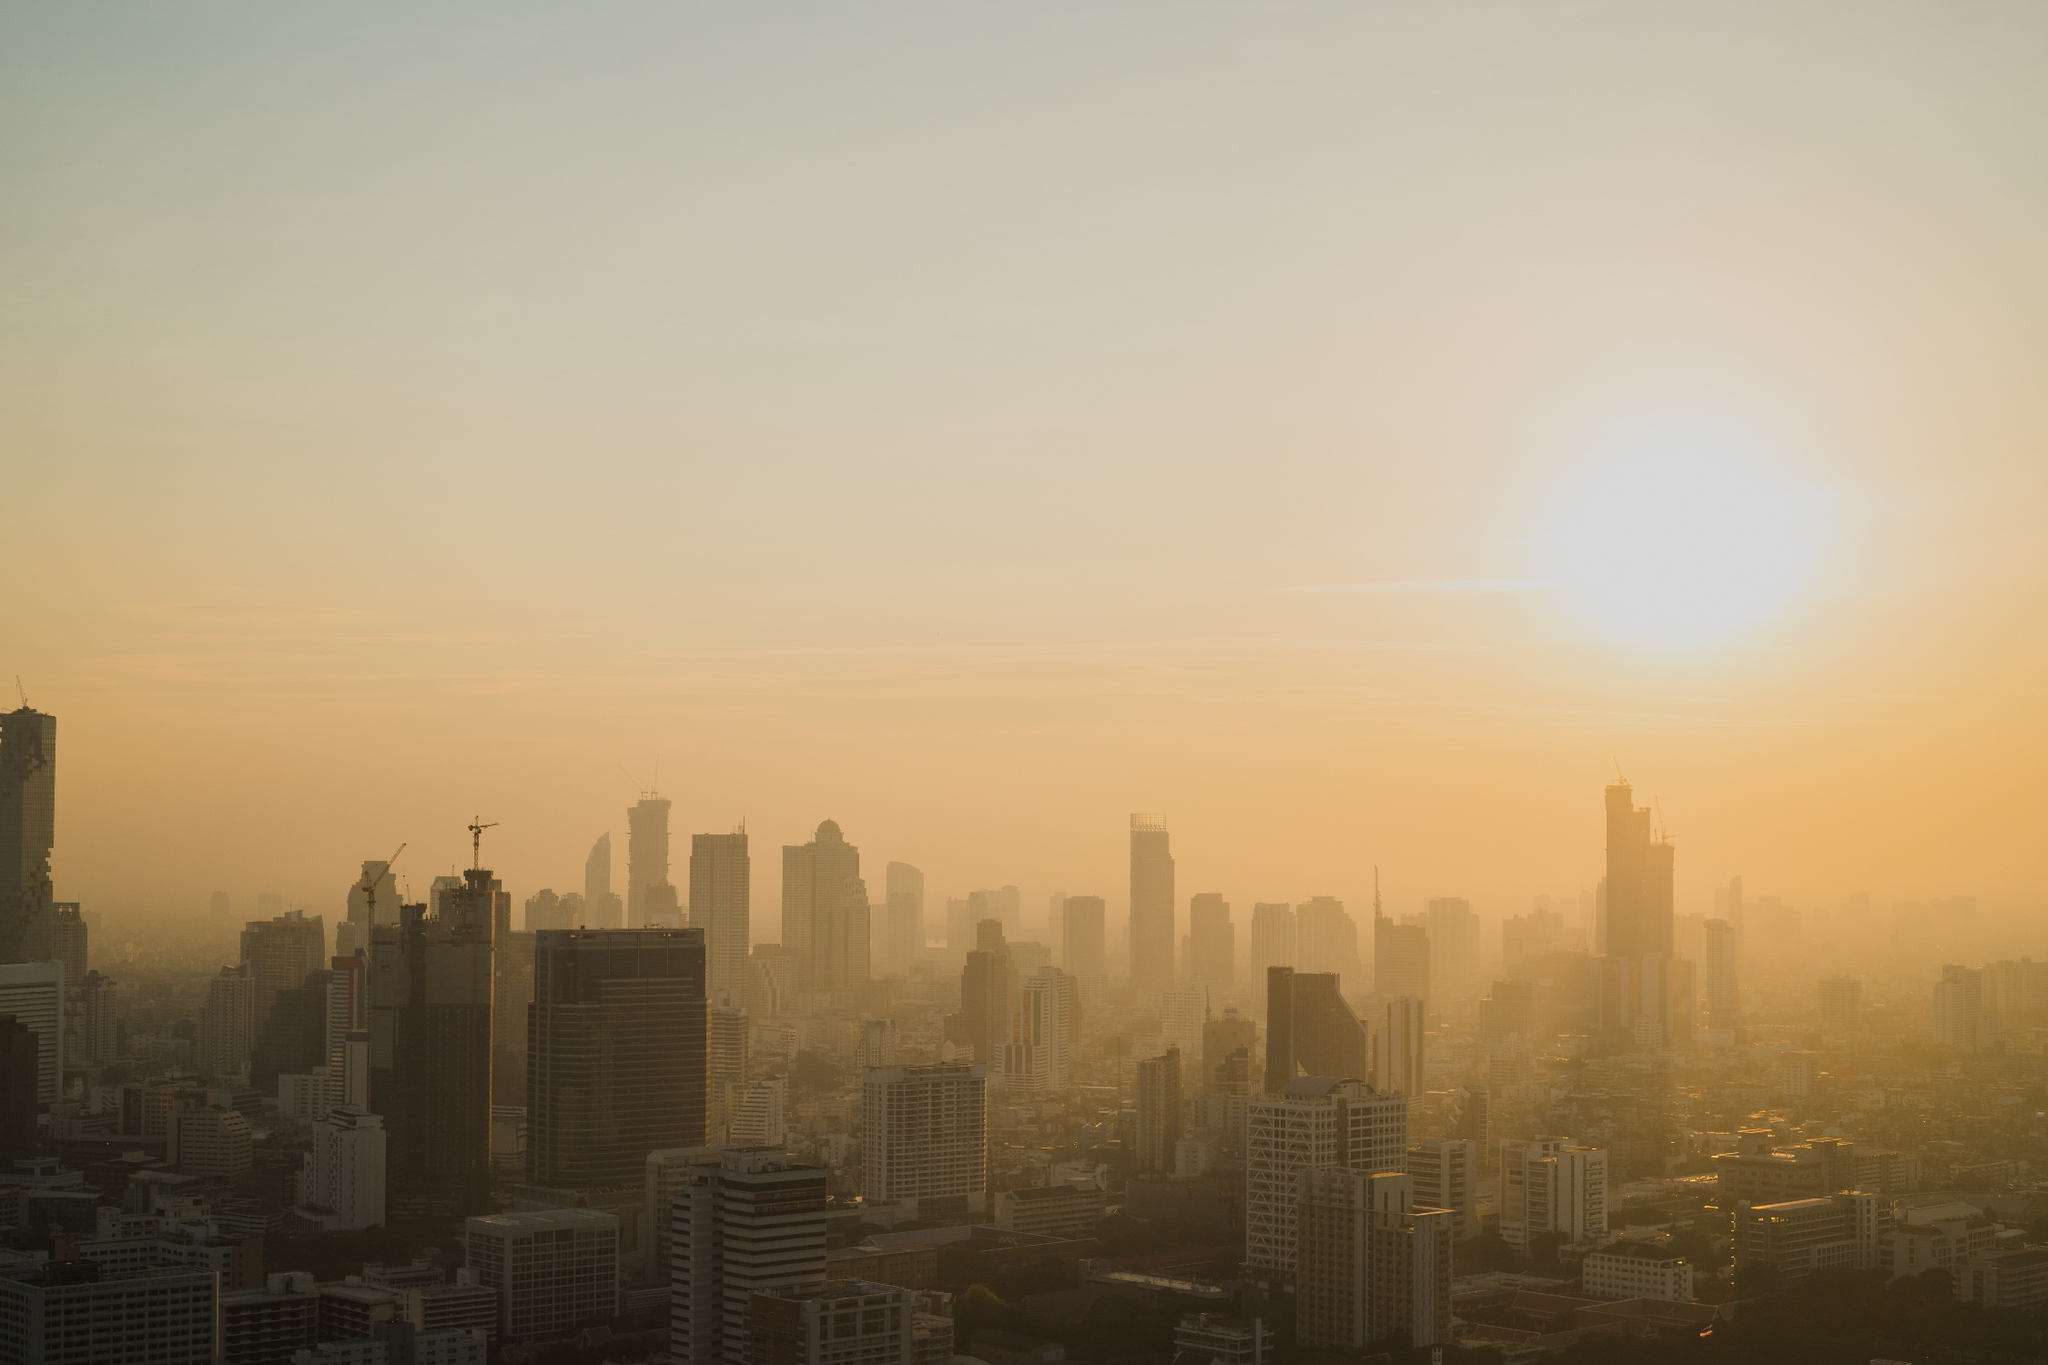Analyze the image in a comprehensive and detailed manner. The image reveals a breathtaking view of a city skyline enveloped in the soft light of early morning. The sun, on the cusp of rising, casts a gentle orange glow, suggesting it is either dawn or dusk. The gradient of color in the sky, transitioning from a light amber to a deeper orange, suggests pollution, which is common in rapidly growing urban environments. Shadowy outlines of numerous skyscrapers and various architectural designs indicate a bustling metropolis. The absence of visible activity in the form of cars or people, coupled with the tranquil ambience of the lighting, evokes a sense of serene anticipation for the day ahead. The photo does not provide significant details such as street names or landmarks, making it difficult to ascertain specific information about the city's geography or key features. 